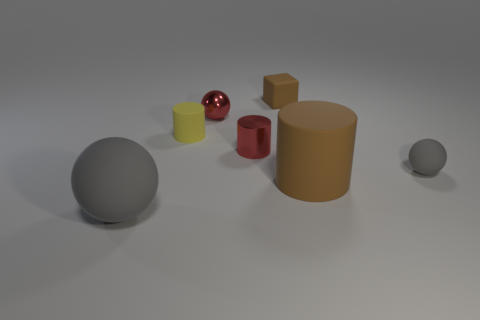Which objects in the image appear to have a reflective surface? The sphere and the cube on the left side have reflective surfaces, as indicated by the visible highlights and the way they interact with the light, showing off their glossy finish. 